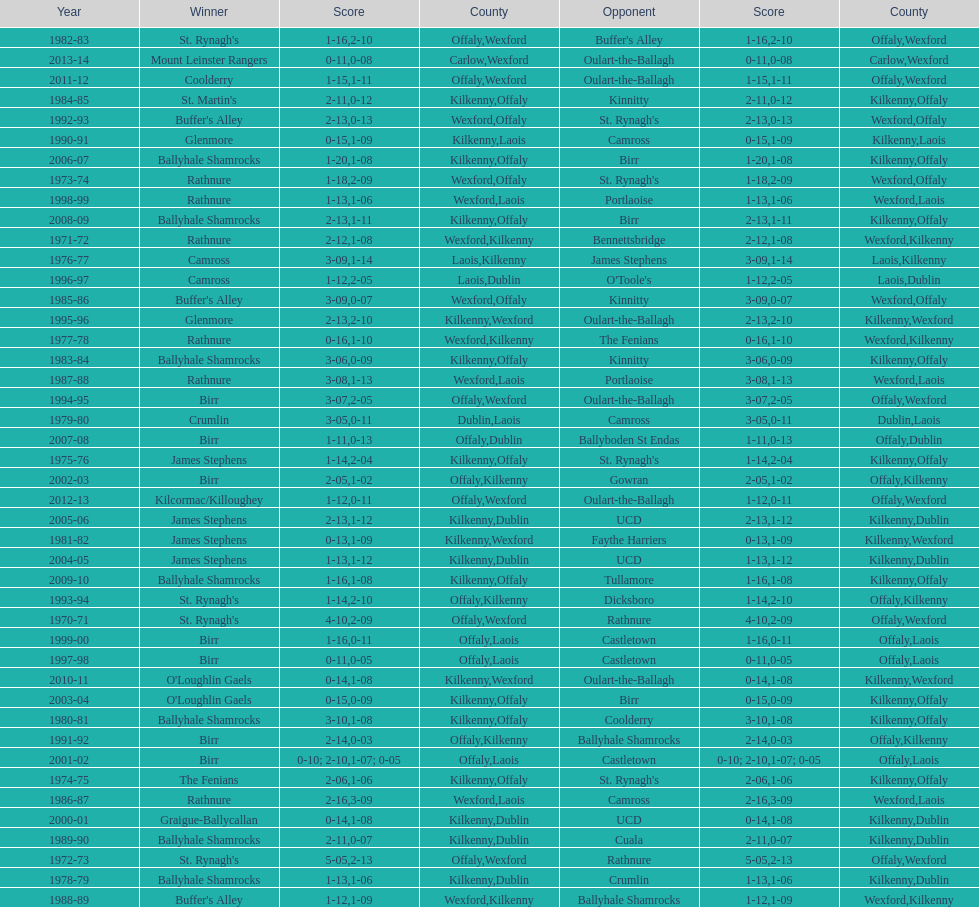Which team won the leinster senior club hurling championships previous to the last time birr won? Ballyhale Shamrocks. 